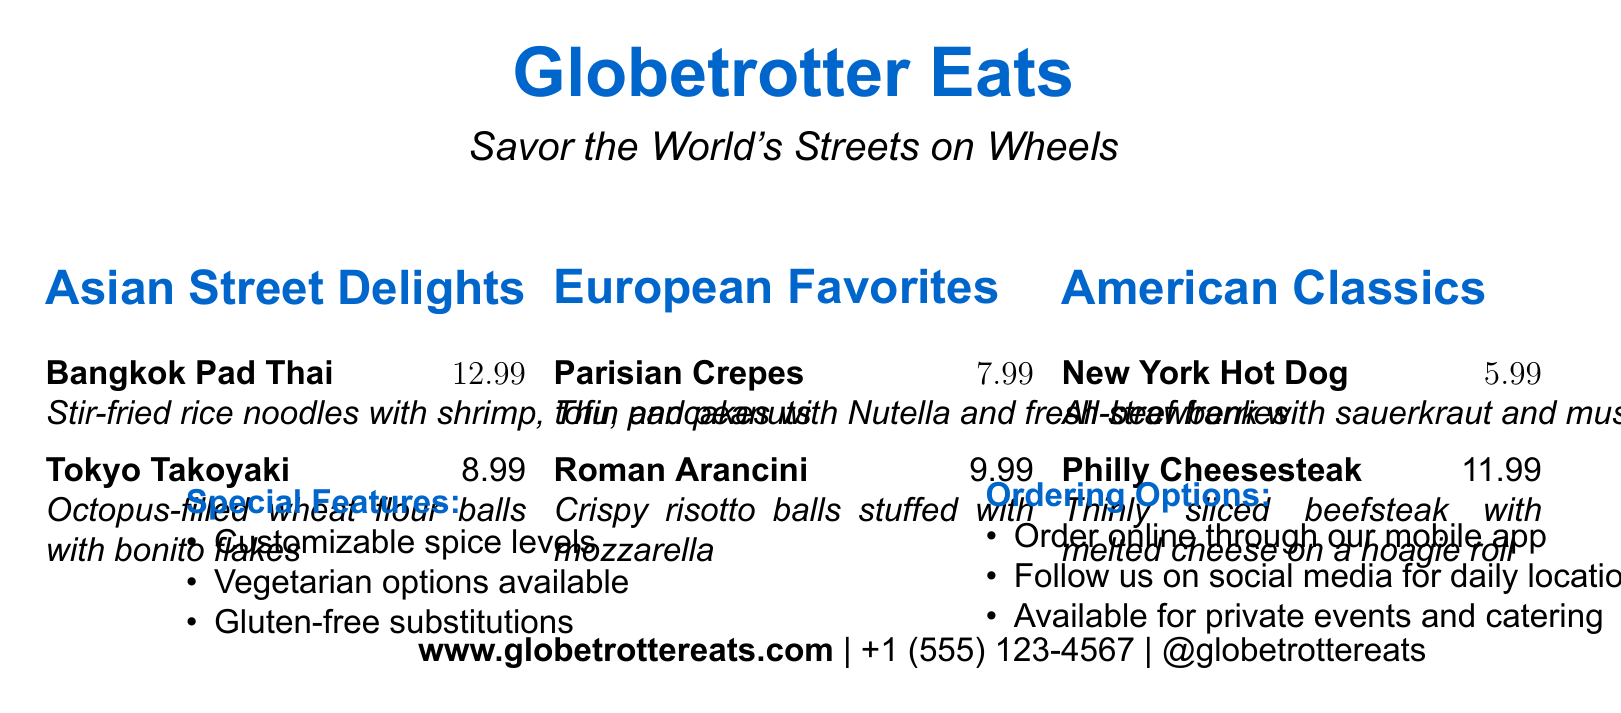What is the name of the food truck? The name of the food truck is mentioned at the top of the document in a prominent manner.
Answer: Globetrotter Eats What is the price of the Tokyo Takoyaki? The price of the Tokyo Takoyaki can be found next to its description in the Asian Street Delights section.
Answer: $8.99 What type of cuisine is featured under American Classics? This category includes classic dishes from a specific region in the context of street foods.
Answer: American Which dessert option is listed in the European Favorites? The document lists a specific dessert under this category, which is made of pancakes.
Answer: Parisian Crepes How many noodle dishes are on the menu? The total number of noodle dishes can be counted from the Asian Street Delights section of the menu.
Answer: 1 What customization options are available? This question addresses the features highlighted in the special features section of the document.
Answer: Customizable spice levels Are gluten-free substitutions offered? This question checks for specific dietary options mentioned in the document.
Answer: Yes How can customers place an order? This question refers to the options provided for ordering in the document.
Answer: Online through our mobile app How can customers follow the food truck's location? The document specifies how customers can stay updated on the food truck's daily location.
Answer: Social media What is the contact number provided? The contact information is prominently displayed at the bottom of the document.
Answer: +1 (555) 123-4567 